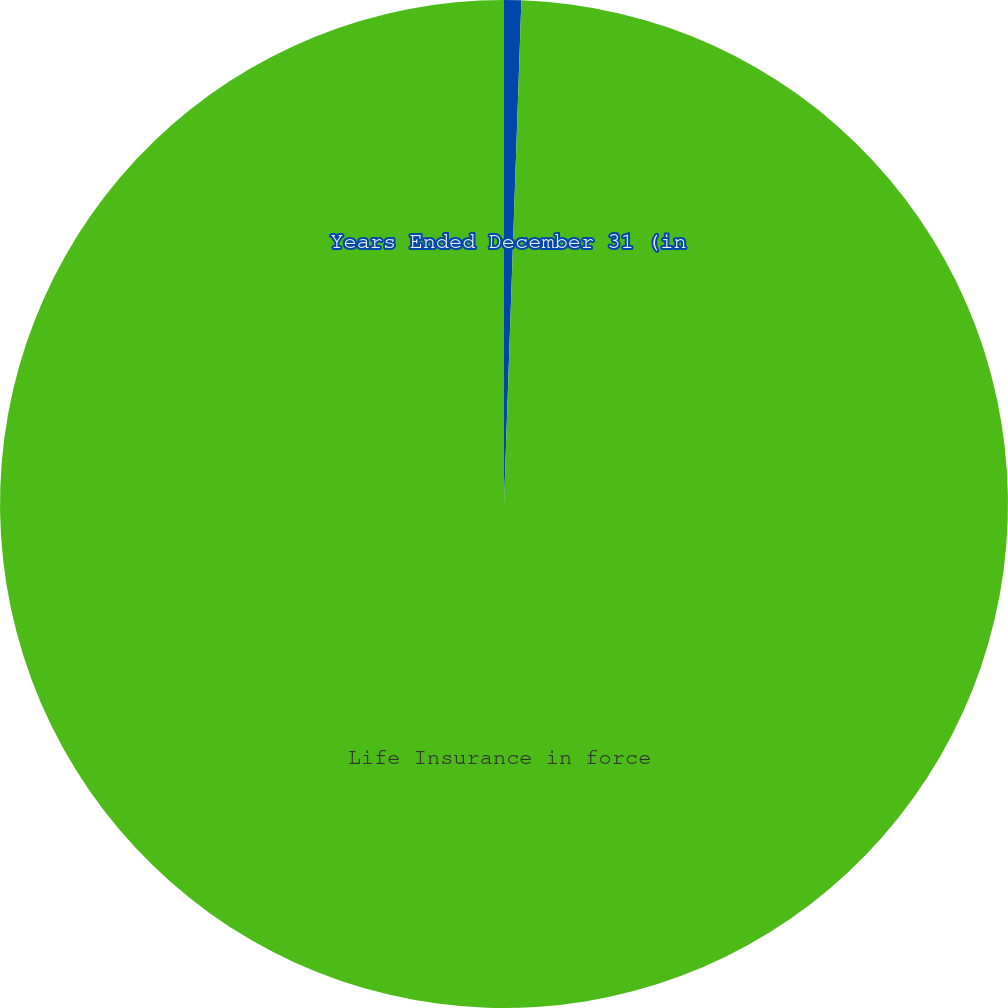<chart> <loc_0><loc_0><loc_500><loc_500><pie_chart><fcel>Years Ended December 31 (in<fcel>Life Insurance in force<nl><fcel>0.55%<fcel>99.45%<nl></chart> 